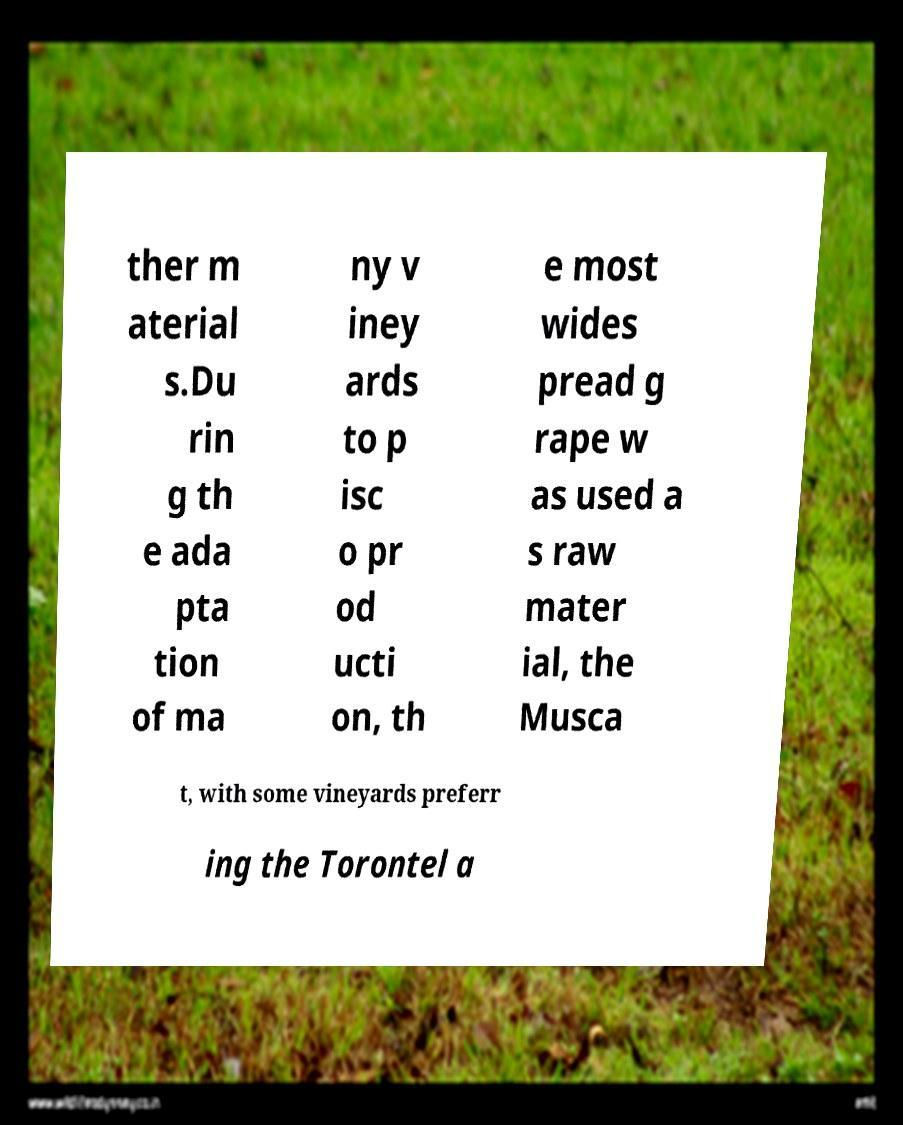What messages or text are displayed in this image? I need them in a readable, typed format. ther m aterial s.Du rin g th e ada pta tion of ma ny v iney ards to p isc o pr od ucti on, th e most wides pread g rape w as used a s raw mater ial, the Musca t, with some vineyards preferr ing the Torontel a 